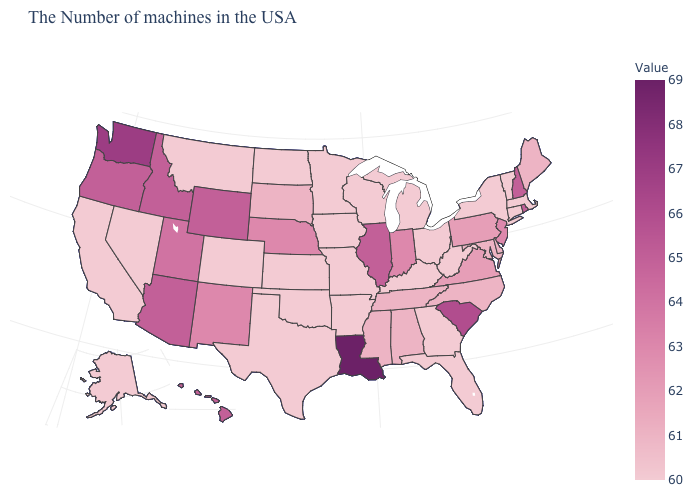Is the legend a continuous bar?
Be succinct. Yes. Which states hav the highest value in the South?
Short answer required. Louisiana. Does Illinois have the highest value in the MidWest?
Be succinct. Yes. Among the states that border Wisconsin , which have the highest value?
Be succinct. Illinois. Does Pennsylvania have the lowest value in the USA?
Quick response, please. No. 